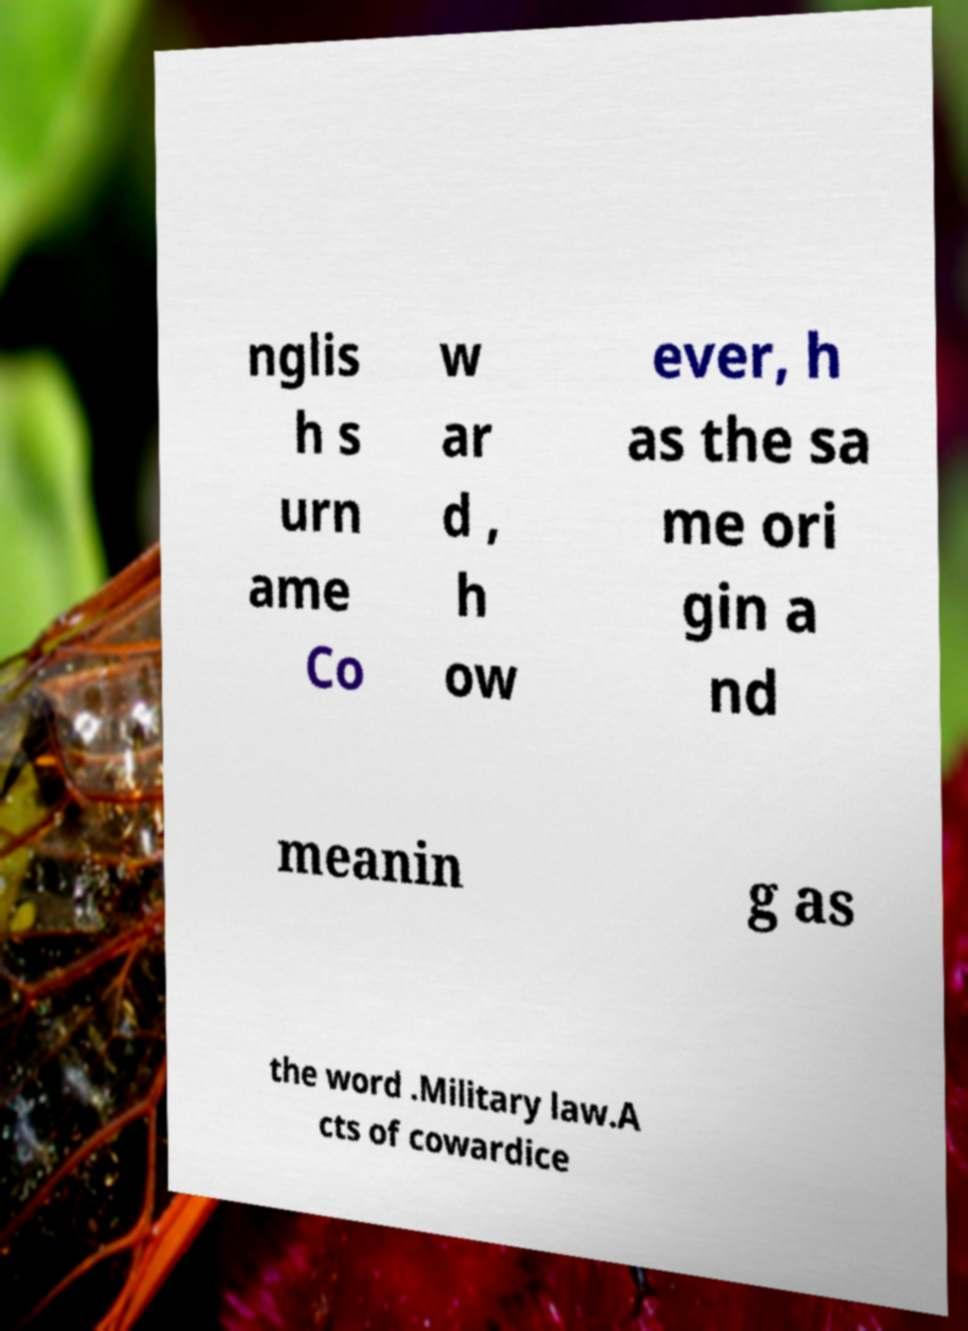Could you assist in decoding the text presented in this image and type it out clearly? nglis h s urn ame Co w ar d , h ow ever, h as the sa me ori gin a nd meanin g as the word .Military law.A cts of cowardice 